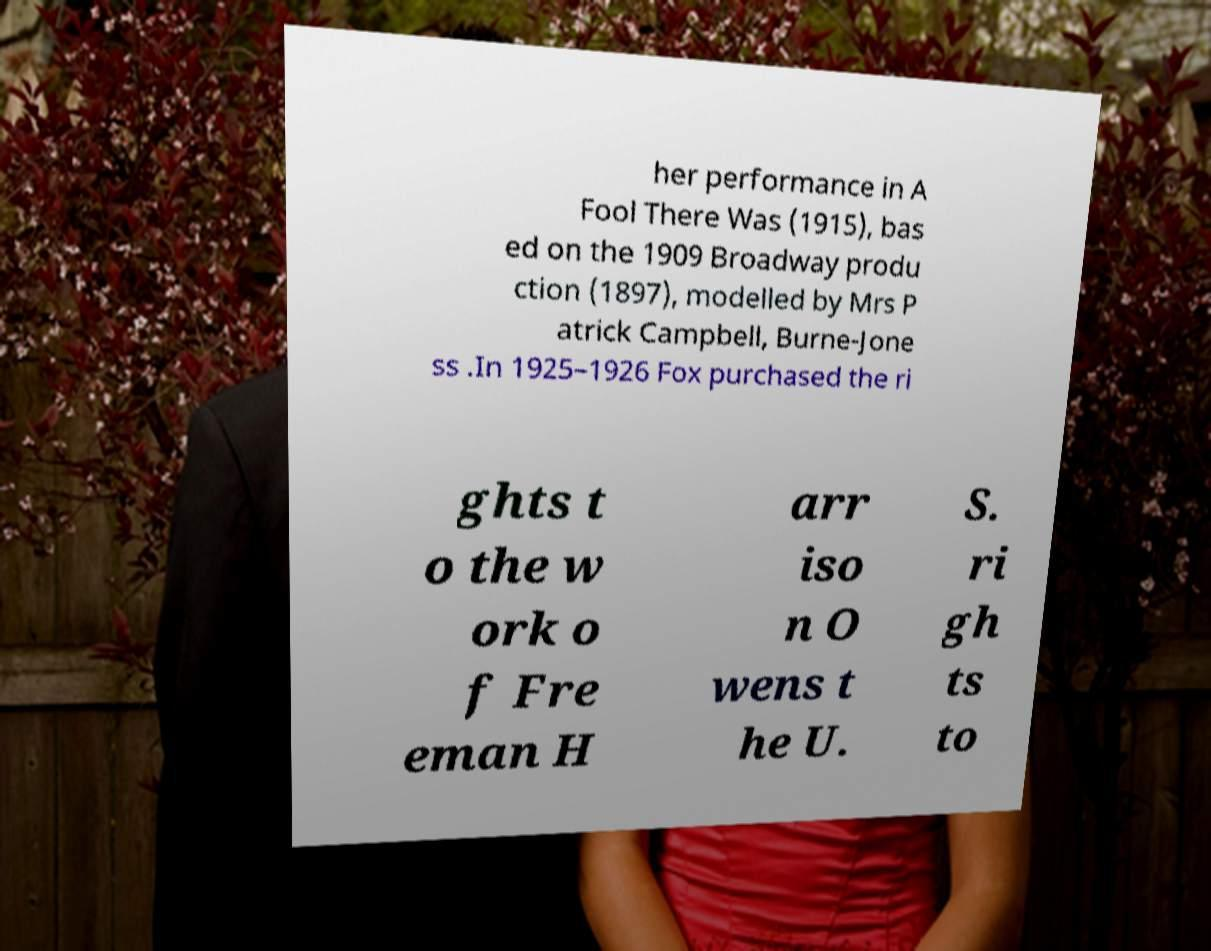Can you read and provide the text displayed in the image?This photo seems to have some interesting text. Can you extract and type it out for me? her performance in A Fool There Was (1915), bas ed on the 1909 Broadway produ ction (1897), modelled by Mrs P atrick Campbell, Burne-Jone ss .In 1925–1926 Fox purchased the ri ghts t o the w ork o f Fre eman H arr iso n O wens t he U. S. ri gh ts to 